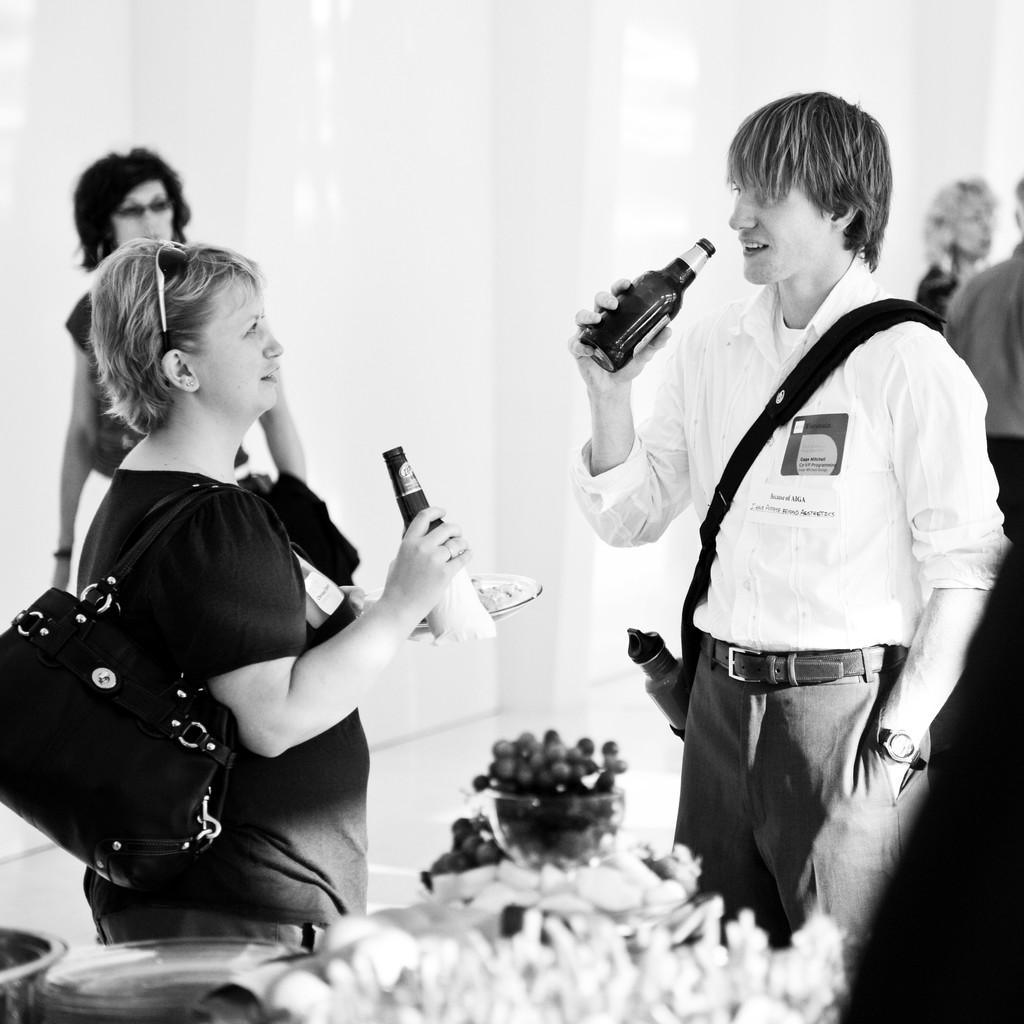What are the people in the image doing? The people in the image are standing and holding bottles. What can be seen in the background of the image? There is a table in the background of the image. What is on the table in the image? There are bowls and fruits on the table. What type of coat is the carpenter wearing in the image? There is no carpenter or coat present in the image. How many knots are visible on the table in the image? There are no knots visible on the table in the image. 